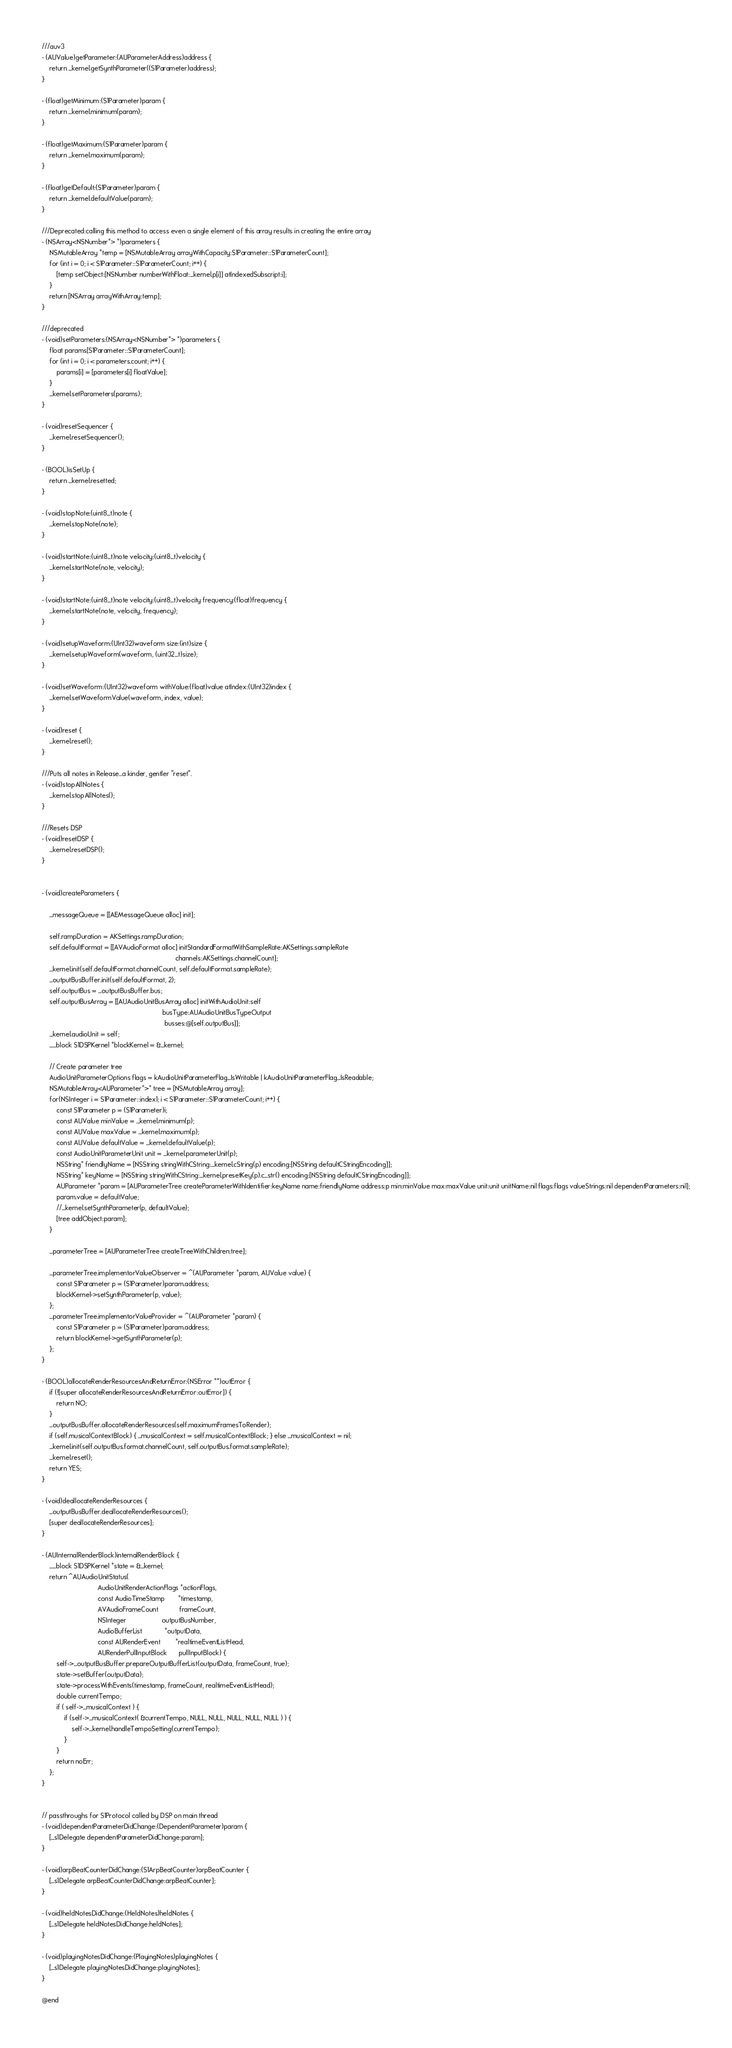<code> <loc_0><loc_0><loc_500><loc_500><_ObjectiveC_>
///auv3
- (AUValue)getParameter:(AUParameterAddress)address {
    return _kernel.getSynthParameter((S1Parameter)address);
}

- (float)getMinimum:(S1Parameter)param {
    return _kernel.minimum(param);
}

- (float)getMaximum:(S1Parameter)param {
    return _kernel.maximum(param);
}

- (float)getDefault:(S1Parameter)param {
    return _kernel.defaultValue(param);
}

///Deprecated:calling this method to access even a single element of this array results in creating the entire array
- (NSArray<NSNumber*> *)parameters {
    NSMutableArray *temp = [NSMutableArray arrayWithCapacity:S1Parameter::S1ParameterCount];
    for (int i = 0; i < S1Parameter::S1ParameterCount; i++) {
        [temp setObject:[NSNumber numberWithFloat:_kernel.p[i]] atIndexedSubscript:i];
    }
    return [NSArray arrayWithArray:temp];
}

///deprecated
- (void)setParameters:(NSArray<NSNumber*> *)parameters {
    float params[S1Parameter::S1ParameterCount];
    for (int i = 0; i < parameters.count; i++) {
        params[i] = [parameters[i] floatValue];
    }
    _kernel.setParameters(params);
}

- (void)resetSequencer {
    _kernel.resetSequencer();
}

- (BOOL)isSetUp {
    return _kernel.resetted;
}

- (void)stopNote:(uint8_t)note {
    _kernel.stopNote(note);
}

- (void)startNote:(uint8_t)note velocity:(uint8_t)velocity {
    _kernel.startNote(note, velocity);
}

- (void)startNote:(uint8_t)note velocity:(uint8_t)velocity frequency:(float)frequency {
    _kernel.startNote(note, velocity, frequency);
}

- (void)setupWaveform:(UInt32)waveform size:(int)size {
    _kernel.setupWaveform(waveform, (uint32_t)size);
}

- (void)setWaveform:(UInt32)waveform withValue:(float)value atIndex:(UInt32)index {
    _kernel.setWaveformValue(waveform, index, value);
}

- (void)reset {
    _kernel.reset();
}

///Puts all notes in Release...a kinder, gentler "reset".
- (void)stopAllNotes {
    _kernel.stopAllNotes();
}

///Resets DSP
- (void)resetDSP {
    _kernel.resetDSP();
}


- (void)createParameters {

    _messageQueue = [[AEMessageQueue alloc] init];

    self.rampDuration = AKSettings.rampDuration;
    self.defaultFormat = [[AVAudioFormat alloc] initStandardFormatWithSampleRate:AKSettings.sampleRate
                                                                        channels:AKSettings.channelCount];
    _kernel.init(self.defaultFormat.channelCount, self.defaultFormat.sampleRate);
    _outputBusBuffer.init(self.defaultFormat, 2);
    self.outputBus = _outputBusBuffer.bus;
    self.outputBusArray = [[AUAudioUnitBusArray alloc] initWithAudioUnit:self
                                                                 busType:AUAudioUnitBusTypeOutput
                                                                  busses:@[self.outputBus]];
    _kernel.audioUnit = self;
    __block S1DSPKernel *blockKernel = &_kernel;
    
    // Create parameter tree
    AudioUnitParameterOptions flags = kAudioUnitParameterFlag_IsWritable | kAudioUnitParameterFlag_IsReadable;
    NSMutableArray<AUParameter*>* tree = [NSMutableArray array];
    for(NSInteger i = S1Parameter::index1; i < S1Parameter::S1ParameterCount; i++) {
        const S1Parameter p = (S1Parameter)i;
        const AUValue minValue = _kernel.minimum(p);
        const AUValue maxValue = _kernel.maximum(p);
        const AUValue defaultValue = _kernel.defaultValue(p);
        const AudioUnitParameterUnit unit = _kernel.parameterUnit(p);
        NSString* friendlyName = [NSString stringWithCString:_kernel.cString(p) encoding:[NSString defaultCStringEncoding]];
        NSString* keyName = [NSString stringWithCString:_kernel.presetKey(p).c_str() encoding:[NSString defaultCStringEncoding]];
        AUParameter *param = [AUParameterTree createParameterWithIdentifier:keyName name:friendlyName address:p min:minValue max:maxValue unit:unit unitName:nil flags:flags valueStrings:nil dependentParameters:nil];
        param.value = defaultValue;
        //_kernel.setSynthParameter(p, defaultValue);
        [tree addObject:param];
    }
    
    _parameterTree = [AUParameterTree createTreeWithChildren:tree];
    
    _parameterTree.implementorValueObserver = ^(AUParameter *param, AUValue value) {
        const S1Parameter p = (S1Parameter)param.address;
        blockKernel->setSynthParameter(p, value);
    };
    _parameterTree.implementorValueProvider = ^(AUParameter *param) {
        const S1Parameter p = (S1Parameter)param.address;
        return blockKernel->getSynthParameter(p);
    };
}

- (BOOL)allocateRenderResourcesAndReturnError:(NSError **)outError {
    if (![super allocateRenderResourcesAndReturnError:outError]) {
        return NO;
    }
    _outputBusBuffer.allocateRenderResources(self.maximumFramesToRender);
    if (self.musicalContextBlock) { _musicalContext = self.musicalContextBlock; } else _musicalContext = nil;
    _kernel.init(self.outputBus.format.channelCount, self.outputBus.format.sampleRate);
    _kernel.reset();
    return YES;
}

- (void)deallocateRenderResources {
    _outputBusBuffer.deallocateRenderResources();
    [super deallocateRenderResources];
}

- (AUInternalRenderBlock)internalRenderBlock {
    __block S1DSPKernel *state = &_kernel;
    return ^AUAudioUnitStatus(
                              AudioUnitRenderActionFlags *actionFlags,
                              const AudioTimeStamp       *timestamp,
                              AVAudioFrameCount           frameCount,
                              NSInteger                   outputBusNumber,
                              AudioBufferList            *outputData,
                              const AURenderEvent        *realtimeEventListHead,
                              AURenderPullInputBlock      pullInputBlock) {
        self->_outputBusBuffer.prepareOutputBufferList(outputData, frameCount, true);
        state->setBuffer(outputData);
        state->processWithEvents(timestamp, frameCount, realtimeEventListHead);
        double currentTempo;
        if ( self->_musicalContext ) {
            if (self->_musicalContext( &currentTempo, NULL, NULL, NULL, NULL, NULL ) ) {
                self->_kernel.handleTempoSetting(currentTempo);
            }
        }
        return noErr;
    };
}


// passthroughs for S1Protocol called by DSP on main thread
- (void)dependentParameterDidChange:(DependentParameter)param {
    [_s1Delegate dependentParameterDidChange:param];
}

- (void)arpBeatCounterDidChange:(S1ArpBeatCounter)arpBeatCounter {
    [_s1Delegate arpBeatCounterDidChange:arpBeatCounter];
}

- (void)heldNotesDidChange:(HeldNotes)heldNotes {
    [_s1Delegate heldNotesDidChange:heldNotes];
}

- (void)playingNotesDidChange:(PlayingNotes)playingNotes {
    [_s1Delegate playingNotesDidChange:playingNotes];
}

@end
</code> 